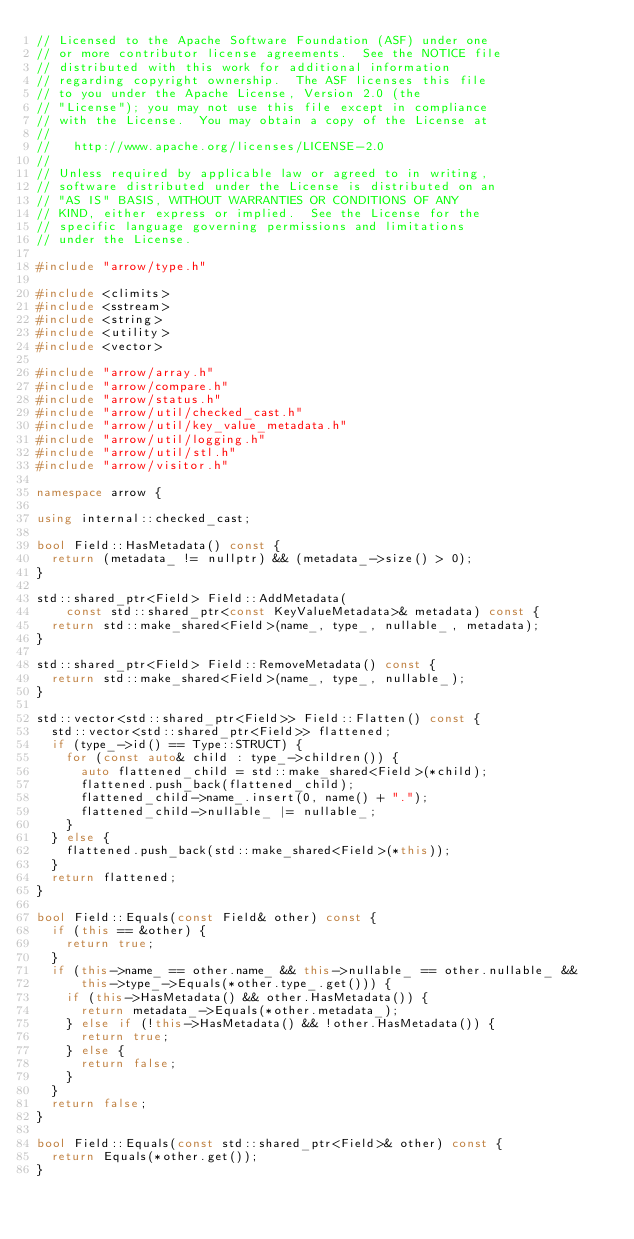<code> <loc_0><loc_0><loc_500><loc_500><_C++_>// Licensed to the Apache Software Foundation (ASF) under one
// or more contributor license agreements.  See the NOTICE file
// distributed with this work for additional information
// regarding copyright ownership.  The ASF licenses this file
// to you under the Apache License, Version 2.0 (the
// "License"); you may not use this file except in compliance
// with the License.  You may obtain a copy of the License at
//
//   http://www.apache.org/licenses/LICENSE-2.0
//
// Unless required by applicable law or agreed to in writing,
// software distributed under the License is distributed on an
// "AS IS" BASIS, WITHOUT WARRANTIES OR CONDITIONS OF ANY
// KIND, either express or implied.  See the License for the
// specific language governing permissions and limitations
// under the License.

#include "arrow/type.h"

#include <climits>
#include <sstream>
#include <string>
#include <utility>
#include <vector>

#include "arrow/array.h"
#include "arrow/compare.h"
#include "arrow/status.h"
#include "arrow/util/checked_cast.h"
#include "arrow/util/key_value_metadata.h"
#include "arrow/util/logging.h"
#include "arrow/util/stl.h"
#include "arrow/visitor.h"

namespace arrow {

using internal::checked_cast;

bool Field::HasMetadata() const {
  return (metadata_ != nullptr) && (metadata_->size() > 0);
}

std::shared_ptr<Field> Field::AddMetadata(
    const std::shared_ptr<const KeyValueMetadata>& metadata) const {
  return std::make_shared<Field>(name_, type_, nullable_, metadata);
}

std::shared_ptr<Field> Field::RemoveMetadata() const {
  return std::make_shared<Field>(name_, type_, nullable_);
}

std::vector<std::shared_ptr<Field>> Field::Flatten() const {
  std::vector<std::shared_ptr<Field>> flattened;
  if (type_->id() == Type::STRUCT) {
    for (const auto& child : type_->children()) {
      auto flattened_child = std::make_shared<Field>(*child);
      flattened.push_back(flattened_child);
      flattened_child->name_.insert(0, name() + ".");
      flattened_child->nullable_ |= nullable_;
    }
  } else {
    flattened.push_back(std::make_shared<Field>(*this));
  }
  return flattened;
}

bool Field::Equals(const Field& other) const {
  if (this == &other) {
    return true;
  }
  if (this->name_ == other.name_ && this->nullable_ == other.nullable_ &&
      this->type_->Equals(*other.type_.get())) {
    if (this->HasMetadata() && other.HasMetadata()) {
      return metadata_->Equals(*other.metadata_);
    } else if (!this->HasMetadata() && !other.HasMetadata()) {
      return true;
    } else {
      return false;
    }
  }
  return false;
}

bool Field::Equals(const std::shared_ptr<Field>& other) const {
  return Equals(*other.get());
}
</code> 